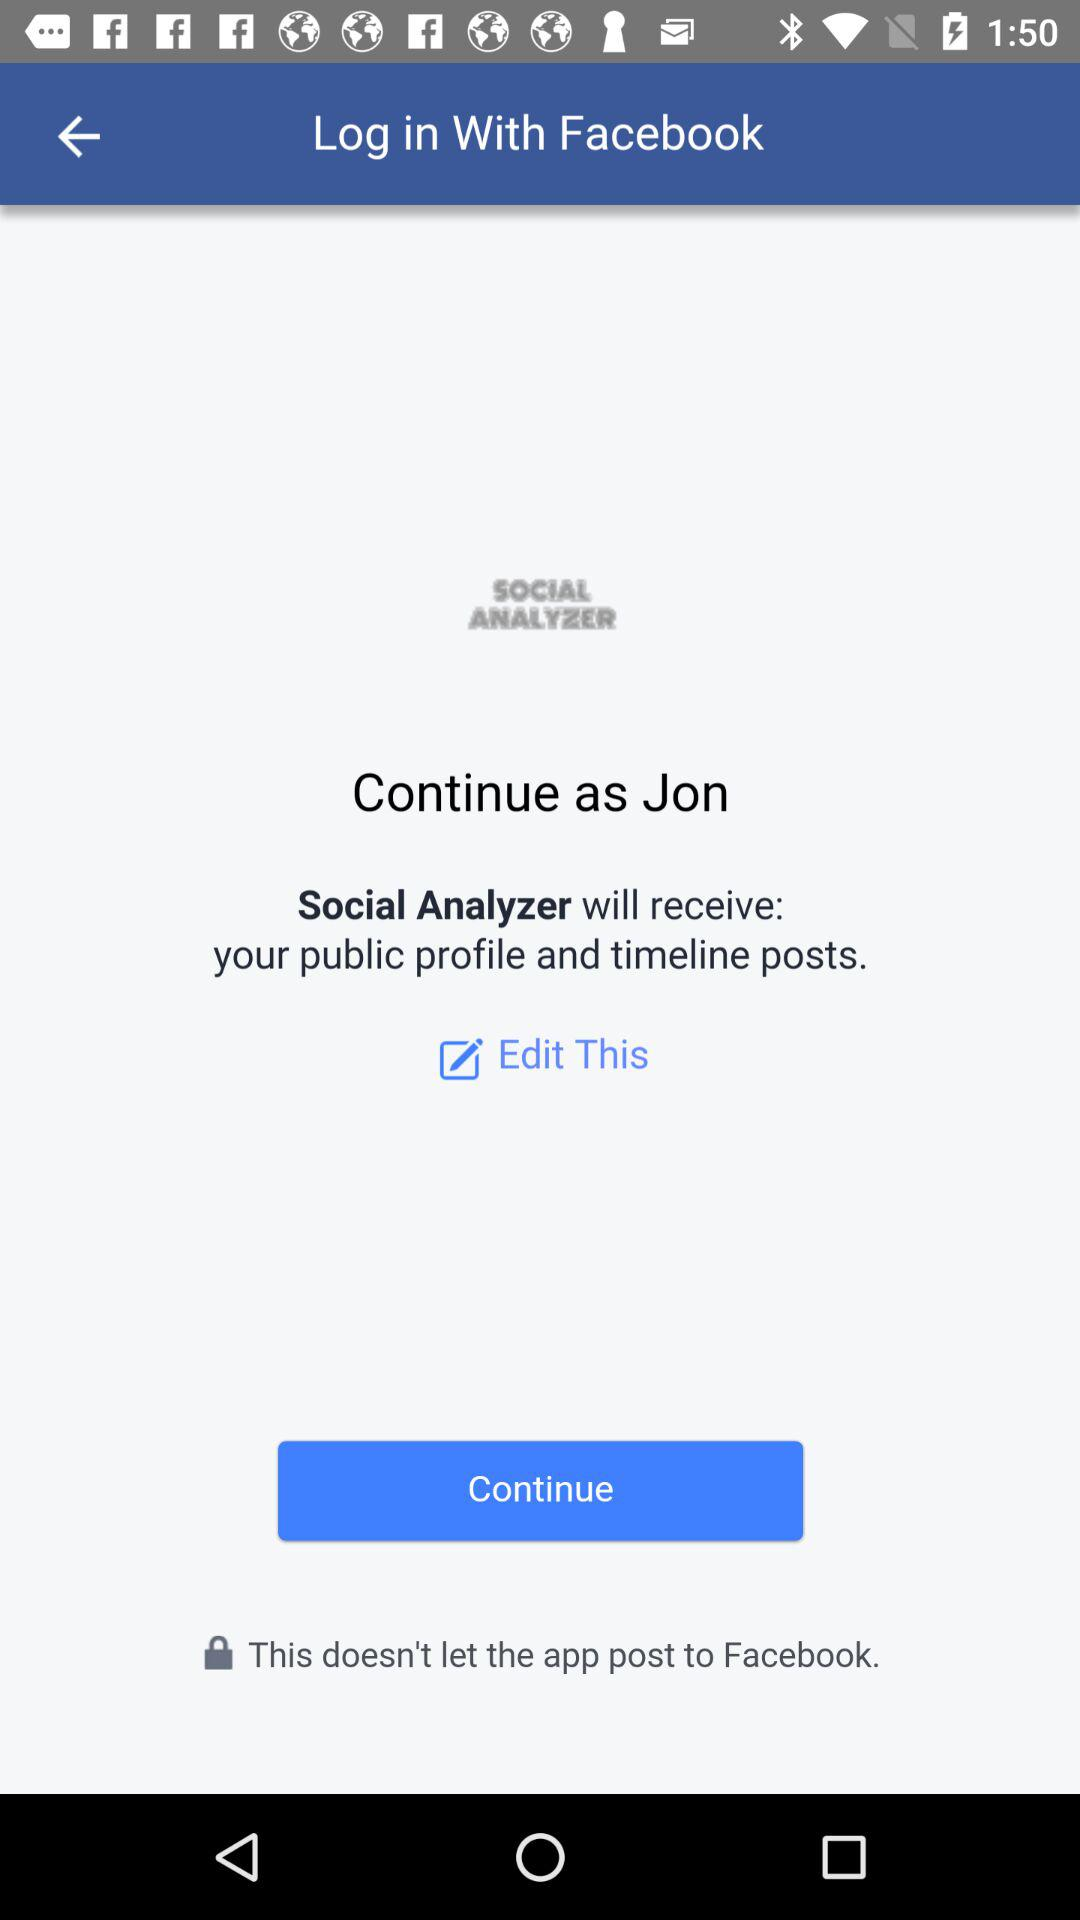What option is available to log in? The available option is "Facebook". 